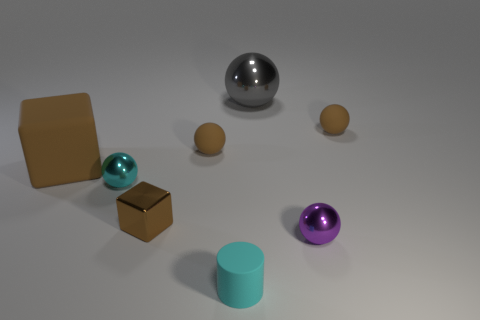What number of things have the same material as the tiny block?
Offer a terse response. 3. There is a tiny thing that is to the left of the brown block in front of the large brown block; what is its color?
Your answer should be very brief. Cyan. How many things are either rubber objects or tiny metallic spheres left of the big gray sphere?
Your answer should be compact. 5. Is there a large rubber object of the same color as the small rubber cylinder?
Your answer should be very brief. No. What number of brown objects are big matte objects or small blocks?
Offer a very short reply. 2. What number of other things are the same size as the metal cube?
Make the answer very short. 5. How many tiny objects are either brown cubes or metallic cubes?
Give a very brief answer. 1. There is a purple thing; is it the same size as the matte object that is left of the small brown metal thing?
Make the answer very short. No. What number of other objects are there of the same shape as the purple thing?
Ensure brevity in your answer.  4. The small cyan object that is made of the same material as the small purple object is what shape?
Provide a short and direct response. Sphere. 